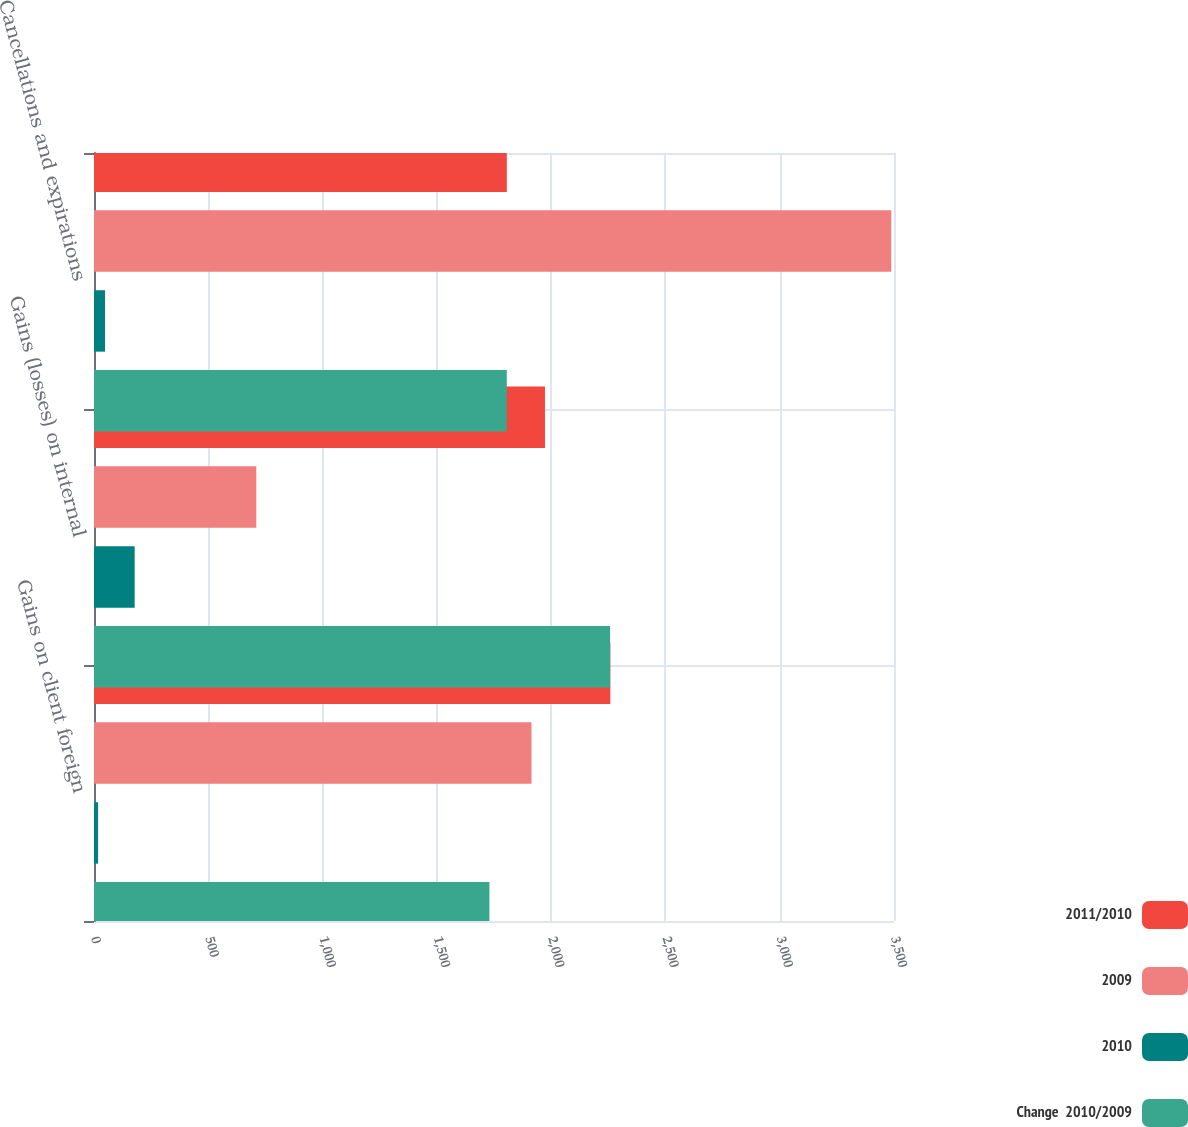<chart> <loc_0><loc_0><loc_500><loc_500><stacked_bar_chart><ecel><fcel>Gains on client foreign<fcel>Gains (losses) on internal<fcel>Cancellations and expirations<nl><fcel>2011/2010<fcel>2259<fcel>1973<fcel>1806<nl><fcel>2009<fcel>1914<fcel>710<fcel>3488<nl><fcel>2010<fcel>18<fcel>177.9<fcel>48.2<nl><fcel>Change  2010/2009<fcel>1730<fcel>2258<fcel>1806<nl></chart> 